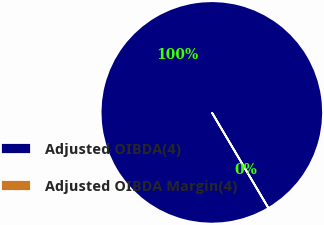Convert chart. <chart><loc_0><loc_0><loc_500><loc_500><pie_chart><fcel>Adjusted OIBDA(4)<fcel>Adjusted OIBDA Margin(4)<nl><fcel>100.0%<fcel>0.0%<nl></chart> 